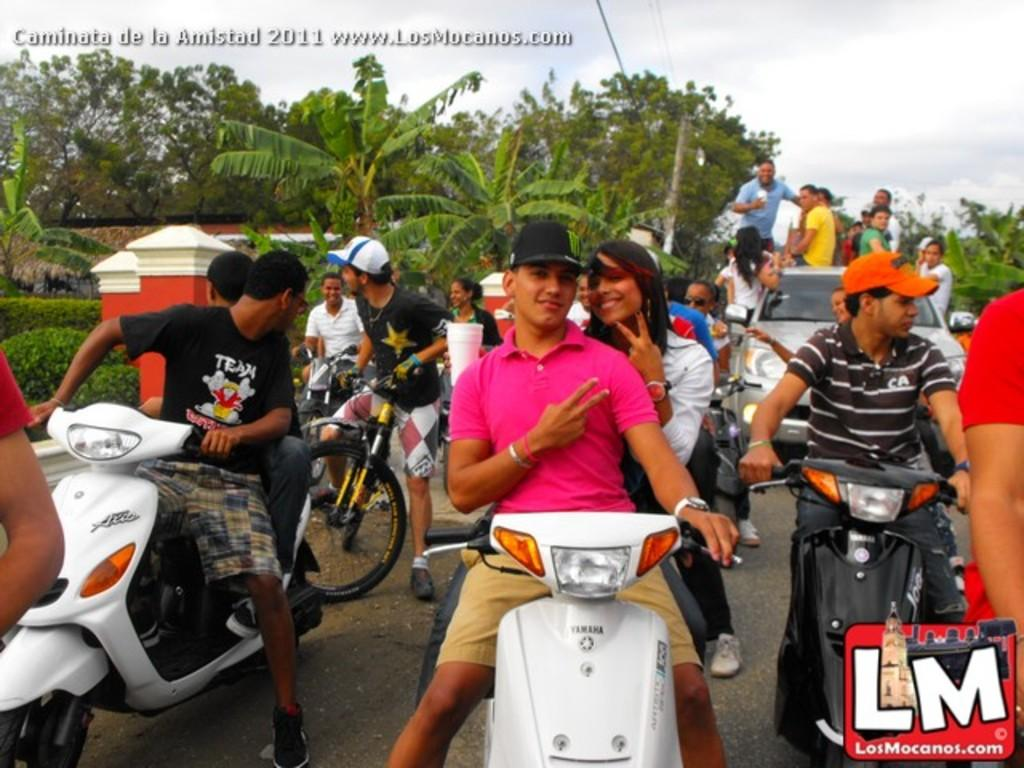What type of vehicles are being ridden by people in the image? There are people riding motorcycles in the image. What other type of vehicle is present in the image? There is a car with people in the image. What can be seen in the background of the image? There are trees visible in the image. Are there any other modes of transportation present in the image? Yes, there are bicycles in the image. What type of stick is being used to learn how to ride a bicycle in the image? There is no stick or toothbrush present in the image. 